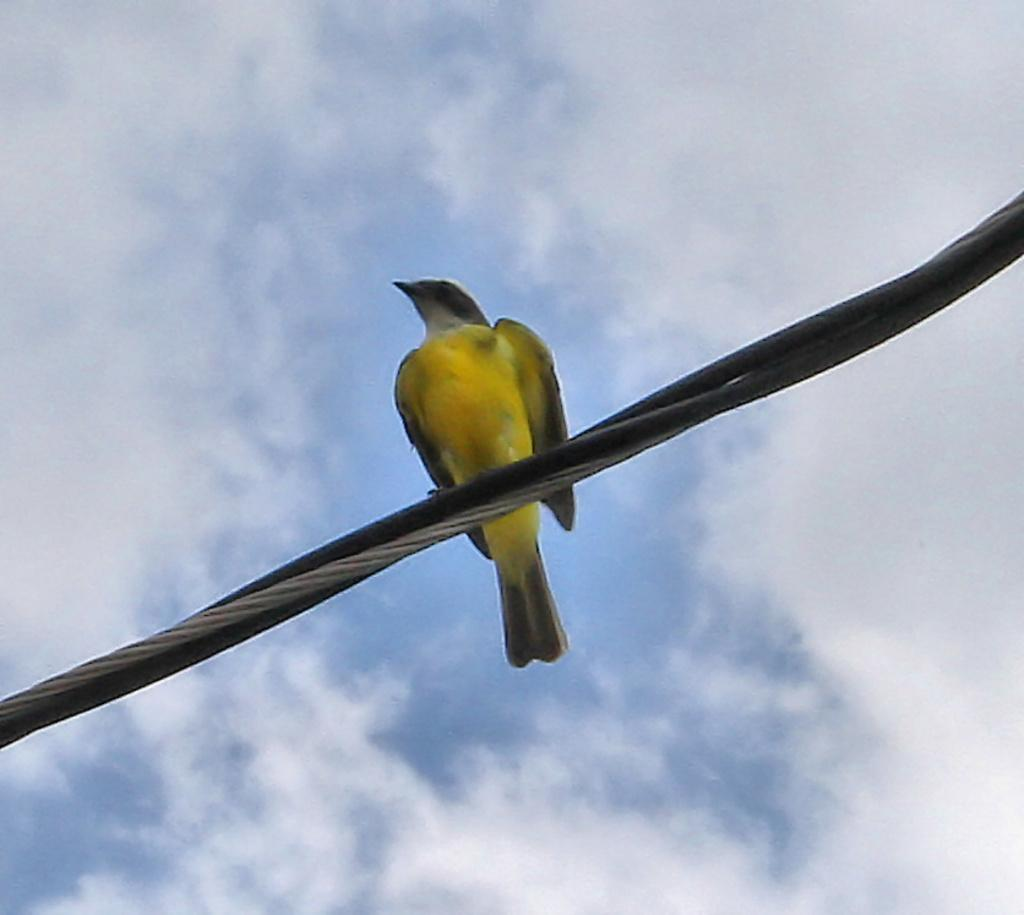What type of animal can be seen in the image? There is a bird in the image. Where is the bird located? The bird is on a wire. What can be seen in the background of the image? The sky is visible in the image. What is the condition of the sky in the image? There are clouds in the sky. What type of popcorn is the donkey eating in the image? There is no donkey or popcorn present in the image; it features a bird on a wire with a visible sky and clouds. 